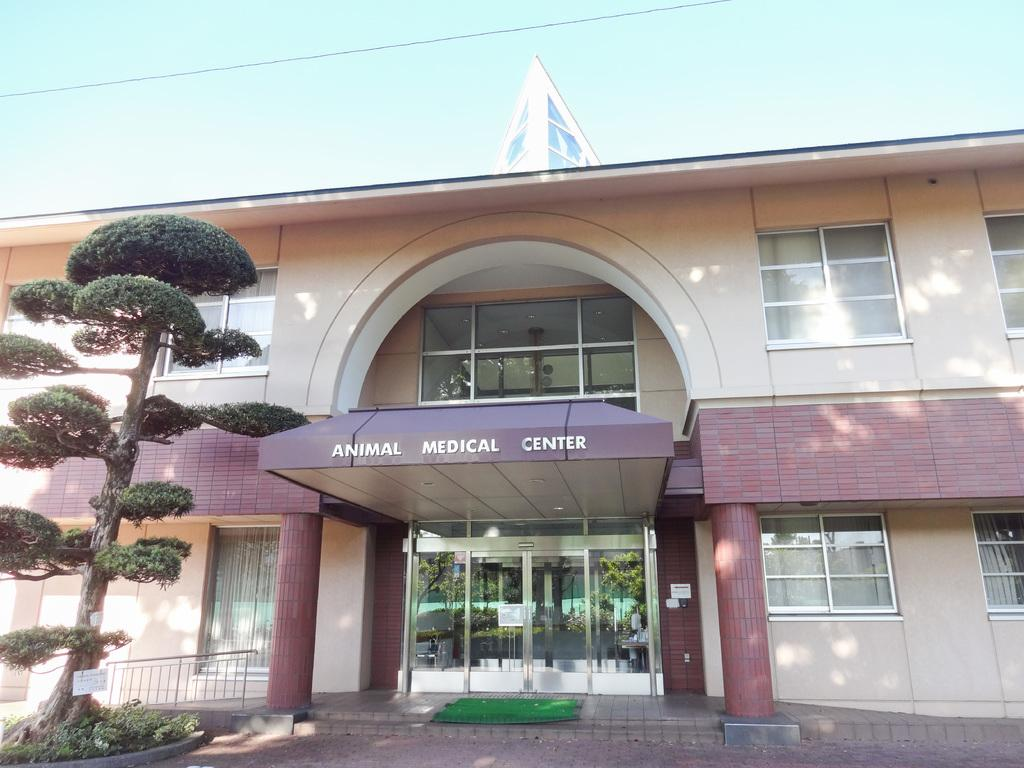<image>
Write a terse but informative summary of the picture. A building with an arch below which is written a sign: "Animal Medical Center". 